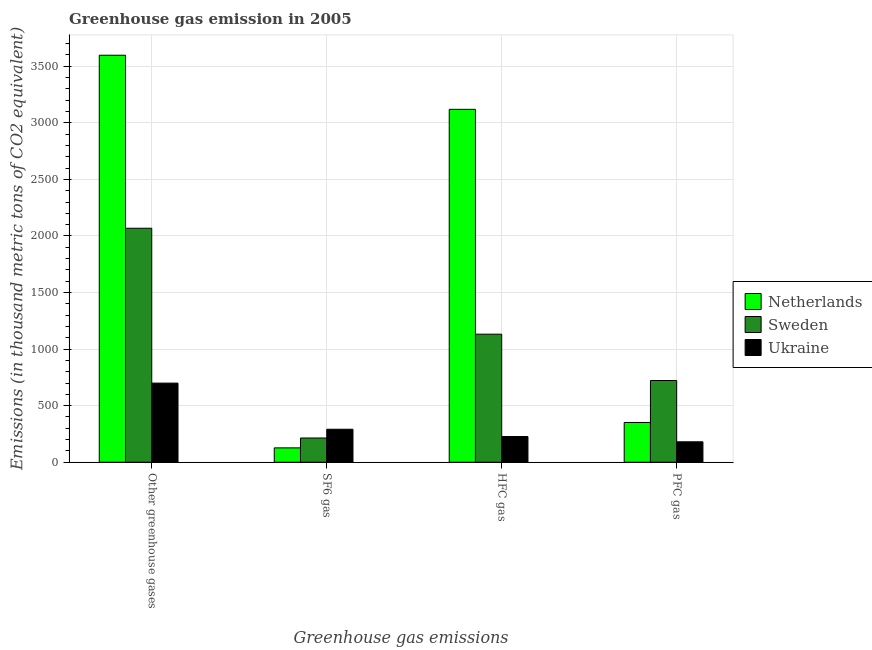How many groups of bars are there?
Your answer should be compact. 4. Are the number of bars per tick equal to the number of legend labels?
Keep it short and to the point. Yes. What is the label of the 2nd group of bars from the left?
Offer a terse response. SF6 gas. What is the emission of pfc gas in Sweden?
Offer a terse response. 722.3. Across all countries, what is the maximum emission of pfc gas?
Ensure brevity in your answer.  722.3. Across all countries, what is the minimum emission of hfc gas?
Make the answer very short. 227.2. In which country was the emission of pfc gas maximum?
Ensure brevity in your answer.  Sweden. What is the total emission of greenhouse gases in the graph?
Give a very brief answer. 6365.5. What is the difference between the emission of greenhouse gases in Netherlands and that in Ukraine?
Your answer should be very brief. 2898.5. What is the difference between the emission of pfc gas in Sweden and the emission of greenhouse gases in Netherlands?
Offer a terse response. -2875.5. What is the average emission of greenhouse gases per country?
Offer a terse response. 2121.83. What is the difference between the emission of hfc gas and emission of pfc gas in Sweden?
Make the answer very short. 409.6. What is the ratio of the emission of hfc gas in Sweden to that in Ukraine?
Make the answer very short. 4.98. What is the difference between the highest and the second highest emission of hfc gas?
Offer a very short reply. 1987.6. What is the difference between the highest and the lowest emission of greenhouse gases?
Give a very brief answer. 2898.5. What does the 3rd bar from the left in Other greenhouse gases represents?
Provide a succinct answer. Ukraine. What does the 1st bar from the right in SF6 gas represents?
Your response must be concise. Ukraine. How many bars are there?
Your answer should be very brief. 12. Are all the bars in the graph horizontal?
Your answer should be very brief. No. How many countries are there in the graph?
Keep it short and to the point. 3. Does the graph contain grids?
Provide a short and direct response. Yes. Where does the legend appear in the graph?
Your answer should be compact. Center right. How many legend labels are there?
Make the answer very short. 3. How are the legend labels stacked?
Give a very brief answer. Vertical. What is the title of the graph?
Offer a terse response. Greenhouse gas emission in 2005. Does "Zambia" appear as one of the legend labels in the graph?
Offer a terse response. No. What is the label or title of the X-axis?
Ensure brevity in your answer.  Greenhouse gas emissions. What is the label or title of the Y-axis?
Offer a terse response. Emissions (in thousand metric tons of CO2 equivalent). What is the Emissions (in thousand metric tons of CO2 equivalent) in Netherlands in Other greenhouse gases?
Your answer should be very brief. 3597.8. What is the Emissions (in thousand metric tons of CO2 equivalent) of Sweden in Other greenhouse gases?
Ensure brevity in your answer.  2068.4. What is the Emissions (in thousand metric tons of CO2 equivalent) of Ukraine in Other greenhouse gases?
Give a very brief answer. 699.3. What is the Emissions (in thousand metric tons of CO2 equivalent) of Netherlands in SF6 gas?
Provide a succinct answer. 126.9. What is the Emissions (in thousand metric tons of CO2 equivalent) in Sweden in SF6 gas?
Provide a succinct answer. 214.2. What is the Emissions (in thousand metric tons of CO2 equivalent) of Ukraine in SF6 gas?
Give a very brief answer. 291.6. What is the Emissions (in thousand metric tons of CO2 equivalent) in Netherlands in HFC gas?
Ensure brevity in your answer.  3119.5. What is the Emissions (in thousand metric tons of CO2 equivalent) in Sweden in HFC gas?
Provide a short and direct response. 1131.9. What is the Emissions (in thousand metric tons of CO2 equivalent) of Ukraine in HFC gas?
Your answer should be compact. 227.2. What is the Emissions (in thousand metric tons of CO2 equivalent) of Netherlands in PFC gas?
Keep it short and to the point. 351.4. What is the Emissions (in thousand metric tons of CO2 equivalent) of Sweden in PFC gas?
Make the answer very short. 722.3. What is the Emissions (in thousand metric tons of CO2 equivalent) in Ukraine in PFC gas?
Provide a succinct answer. 180.5. Across all Greenhouse gas emissions, what is the maximum Emissions (in thousand metric tons of CO2 equivalent) of Netherlands?
Offer a very short reply. 3597.8. Across all Greenhouse gas emissions, what is the maximum Emissions (in thousand metric tons of CO2 equivalent) of Sweden?
Offer a very short reply. 2068.4. Across all Greenhouse gas emissions, what is the maximum Emissions (in thousand metric tons of CO2 equivalent) of Ukraine?
Make the answer very short. 699.3. Across all Greenhouse gas emissions, what is the minimum Emissions (in thousand metric tons of CO2 equivalent) of Netherlands?
Provide a succinct answer. 126.9. Across all Greenhouse gas emissions, what is the minimum Emissions (in thousand metric tons of CO2 equivalent) of Sweden?
Your response must be concise. 214.2. Across all Greenhouse gas emissions, what is the minimum Emissions (in thousand metric tons of CO2 equivalent) of Ukraine?
Provide a succinct answer. 180.5. What is the total Emissions (in thousand metric tons of CO2 equivalent) in Netherlands in the graph?
Your answer should be very brief. 7195.6. What is the total Emissions (in thousand metric tons of CO2 equivalent) in Sweden in the graph?
Give a very brief answer. 4136.8. What is the total Emissions (in thousand metric tons of CO2 equivalent) in Ukraine in the graph?
Give a very brief answer. 1398.6. What is the difference between the Emissions (in thousand metric tons of CO2 equivalent) of Netherlands in Other greenhouse gases and that in SF6 gas?
Your response must be concise. 3470.9. What is the difference between the Emissions (in thousand metric tons of CO2 equivalent) of Sweden in Other greenhouse gases and that in SF6 gas?
Provide a short and direct response. 1854.2. What is the difference between the Emissions (in thousand metric tons of CO2 equivalent) of Ukraine in Other greenhouse gases and that in SF6 gas?
Ensure brevity in your answer.  407.7. What is the difference between the Emissions (in thousand metric tons of CO2 equivalent) of Netherlands in Other greenhouse gases and that in HFC gas?
Your answer should be compact. 478.3. What is the difference between the Emissions (in thousand metric tons of CO2 equivalent) of Sweden in Other greenhouse gases and that in HFC gas?
Offer a very short reply. 936.5. What is the difference between the Emissions (in thousand metric tons of CO2 equivalent) in Ukraine in Other greenhouse gases and that in HFC gas?
Your answer should be compact. 472.1. What is the difference between the Emissions (in thousand metric tons of CO2 equivalent) of Netherlands in Other greenhouse gases and that in PFC gas?
Your answer should be very brief. 3246.4. What is the difference between the Emissions (in thousand metric tons of CO2 equivalent) in Sweden in Other greenhouse gases and that in PFC gas?
Provide a succinct answer. 1346.1. What is the difference between the Emissions (in thousand metric tons of CO2 equivalent) of Ukraine in Other greenhouse gases and that in PFC gas?
Give a very brief answer. 518.8. What is the difference between the Emissions (in thousand metric tons of CO2 equivalent) of Netherlands in SF6 gas and that in HFC gas?
Make the answer very short. -2992.6. What is the difference between the Emissions (in thousand metric tons of CO2 equivalent) of Sweden in SF6 gas and that in HFC gas?
Keep it short and to the point. -917.7. What is the difference between the Emissions (in thousand metric tons of CO2 equivalent) of Ukraine in SF6 gas and that in HFC gas?
Your response must be concise. 64.4. What is the difference between the Emissions (in thousand metric tons of CO2 equivalent) of Netherlands in SF6 gas and that in PFC gas?
Offer a very short reply. -224.5. What is the difference between the Emissions (in thousand metric tons of CO2 equivalent) in Sweden in SF6 gas and that in PFC gas?
Your answer should be very brief. -508.1. What is the difference between the Emissions (in thousand metric tons of CO2 equivalent) of Ukraine in SF6 gas and that in PFC gas?
Offer a terse response. 111.1. What is the difference between the Emissions (in thousand metric tons of CO2 equivalent) in Netherlands in HFC gas and that in PFC gas?
Give a very brief answer. 2768.1. What is the difference between the Emissions (in thousand metric tons of CO2 equivalent) in Sweden in HFC gas and that in PFC gas?
Your answer should be compact. 409.6. What is the difference between the Emissions (in thousand metric tons of CO2 equivalent) in Ukraine in HFC gas and that in PFC gas?
Your response must be concise. 46.7. What is the difference between the Emissions (in thousand metric tons of CO2 equivalent) of Netherlands in Other greenhouse gases and the Emissions (in thousand metric tons of CO2 equivalent) of Sweden in SF6 gas?
Give a very brief answer. 3383.6. What is the difference between the Emissions (in thousand metric tons of CO2 equivalent) in Netherlands in Other greenhouse gases and the Emissions (in thousand metric tons of CO2 equivalent) in Ukraine in SF6 gas?
Your answer should be very brief. 3306.2. What is the difference between the Emissions (in thousand metric tons of CO2 equivalent) in Sweden in Other greenhouse gases and the Emissions (in thousand metric tons of CO2 equivalent) in Ukraine in SF6 gas?
Keep it short and to the point. 1776.8. What is the difference between the Emissions (in thousand metric tons of CO2 equivalent) in Netherlands in Other greenhouse gases and the Emissions (in thousand metric tons of CO2 equivalent) in Sweden in HFC gas?
Provide a short and direct response. 2465.9. What is the difference between the Emissions (in thousand metric tons of CO2 equivalent) in Netherlands in Other greenhouse gases and the Emissions (in thousand metric tons of CO2 equivalent) in Ukraine in HFC gas?
Keep it short and to the point. 3370.6. What is the difference between the Emissions (in thousand metric tons of CO2 equivalent) of Sweden in Other greenhouse gases and the Emissions (in thousand metric tons of CO2 equivalent) of Ukraine in HFC gas?
Give a very brief answer. 1841.2. What is the difference between the Emissions (in thousand metric tons of CO2 equivalent) of Netherlands in Other greenhouse gases and the Emissions (in thousand metric tons of CO2 equivalent) of Sweden in PFC gas?
Your answer should be compact. 2875.5. What is the difference between the Emissions (in thousand metric tons of CO2 equivalent) of Netherlands in Other greenhouse gases and the Emissions (in thousand metric tons of CO2 equivalent) of Ukraine in PFC gas?
Ensure brevity in your answer.  3417.3. What is the difference between the Emissions (in thousand metric tons of CO2 equivalent) of Sweden in Other greenhouse gases and the Emissions (in thousand metric tons of CO2 equivalent) of Ukraine in PFC gas?
Ensure brevity in your answer.  1887.9. What is the difference between the Emissions (in thousand metric tons of CO2 equivalent) of Netherlands in SF6 gas and the Emissions (in thousand metric tons of CO2 equivalent) of Sweden in HFC gas?
Your answer should be compact. -1005. What is the difference between the Emissions (in thousand metric tons of CO2 equivalent) in Netherlands in SF6 gas and the Emissions (in thousand metric tons of CO2 equivalent) in Ukraine in HFC gas?
Provide a short and direct response. -100.3. What is the difference between the Emissions (in thousand metric tons of CO2 equivalent) of Sweden in SF6 gas and the Emissions (in thousand metric tons of CO2 equivalent) of Ukraine in HFC gas?
Your answer should be compact. -13. What is the difference between the Emissions (in thousand metric tons of CO2 equivalent) of Netherlands in SF6 gas and the Emissions (in thousand metric tons of CO2 equivalent) of Sweden in PFC gas?
Keep it short and to the point. -595.4. What is the difference between the Emissions (in thousand metric tons of CO2 equivalent) in Netherlands in SF6 gas and the Emissions (in thousand metric tons of CO2 equivalent) in Ukraine in PFC gas?
Keep it short and to the point. -53.6. What is the difference between the Emissions (in thousand metric tons of CO2 equivalent) in Sweden in SF6 gas and the Emissions (in thousand metric tons of CO2 equivalent) in Ukraine in PFC gas?
Your answer should be very brief. 33.7. What is the difference between the Emissions (in thousand metric tons of CO2 equivalent) of Netherlands in HFC gas and the Emissions (in thousand metric tons of CO2 equivalent) of Sweden in PFC gas?
Your answer should be compact. 2397.2. What is the difference between the Emissions (in thousand metric tons of CO2 equivalent) in Netherlands in HFC gas and the Emissions (in thousand metric tons of CO2 equivalent) in Ukraine in PFC gas?
Provide a short and direct response. 2939. What is the difference between the Emissions (in thousand metric tons of CO2 equivalent) in Sweden in HFC gas and the Emissions (in thousand metric tons of CO2 equivalent) in Ukraine in PFC gas?
Your answer should be very brief. 951.4. What is the average Emissions (in thousand metric tons of CO2 equivalent) of Netherlands per Greenhouse gas emissions?
Offer a very short reply. 1798.9. What is the average Emissions (in thousand metric tons of CO2 equivalent) in Sweden per Greenhouse gas emissions?
Keep it short and to the point. 1034.2. What is the average Emissions (in thousand metric tons of CO2 equivalent) in Ukraine per Greenhouse gas emissions?
Offer a terse response. 349.65. What is the difference between the Emissions (in thousand metric tons of CO2 equivalent) in Netherlands and Emissions (in thousand metric tons of CO2 equivalent) in Sweden in Other greenhouse gases?
Keep it short and to the point. 1529.4. What is the difference between the Emissions (in thousand metric tons of CO2 equivalent) of Netherlands and Emissions (in thousand metric tons of CO2 equivalent) of Ukraine in Other greenhouse gases?
Your answer should be very brief. 2898.5. What is the difference between the Emissions (in thousand metric tons of CO2 equivalent) in Sweden and Emissions (in thousand metric tons of CO2 equivalent) in Ukraine in Other greenhouse gases?
Your response must be concise. 1369.1. What is the difference between the Emissions (in thousand metric tons of CO2 equivalent) in Netherlands and Emissions (in thousand metric tons of CO2 equivalent) in Sweden in SF6 gas?
Your answer should be compact. -87.3. What is the difference between the Emissions (in thousand metric tons of CO2 equivalent) of Netherlands and Emissions (in thousand metric tons of CO2 equivalent) of Ukraine in SF6 gas?
Provide a succinct answer. -164.7. What is the difference between the Emissions (in thousand metric tons of CO2 equivalent) of Sweden and Emissions (in thousand metric tons of CO2 equivalent) of Ukraine in SF6 gas?
Your answer should be compact. -77.4. What is the difference between the Emissions (in thousand metric tons of CO2 equivalent) in Netherlands and Emissions (in thousand metric tons of CO2 equivalent) in Sweden in HFC gas?
Offer a very short reply. 1987.6. What is the difference between the Emissions (in thousand metric tons of CO2 equivalent) of Netherlands and Emissions (in thousand metric tons of CO2 equivalent) of Ukraine in HFC gas?
Provide a succinct answer. 2892.3. What is the difference between the Emissions (in thousand metric tons of CO2 equivalent) in Sweden and Emissions (in thousand metric tons of CO2 equivalent) in Ukraine in HFC gas?
Provide a succinct answer. 904.7. What is the difference between the Emissions (in thousand metric tons of CO2 equivalent) in Netherlands and Emissions (in thousand metric tons of CO2 equivalent) in Sweden in PFC gas?
Give a very brief answer. -370.9. What is the difference between the Emissions (in thousand metric tons of CO2 equivalent) in Netherlands and Emissions (in thousand metric tons of CO2 equivalent) in Ukraine in PFC gas?
Provide a short and direct response. 170.9. What is the difference between the Emissions (in thousand metric tons of CO2 equivalent) of Sweden and Emissions (in thousand metric tons of CO2 equivalent) of Ukraine in PFC gas?
Provide a succinct answer. 541.8. What is the ratio of the Emissions (in thousand metric tons of CO2 equivalent) of Netherlands in Other greenhouse gases to that in SF6 gas?
Give a very brief answer. 28.35. What is the ratio of the Emissions (in thousand metric tons of CO2 equivalent) of Sweden in Other greenhouse gases to that in SF6 gas?
Offer a terse response. 9.66. What is the ratio of the Emissions (in thousand metric tons of CO2 equivalent) of Ukraine in Other greenhouse gases to that in SF6 gas?
Make the answer very short. 2.4. What is the ratio of the Emissions (in thousand metric tons of CO2 equivalent) in Netherlands in Other greenhouse gases to that in HFC gas?
Make the answer very short. 1.15. What is the ratio of the Emissions (in thousand metric tons of CO2 equivalent) of Sweden in Other greenhouse gases to that in HFC gas?
Keep it short and to the point. 1.83. What is the ratio of the Emissions (in thousand metric tons of CO2 equivalent) of Ukraine in Other greenhouse gases to that in HFC gas?
Provide a succinct answer. 3.08. What is the ratio of the Emissions (in thousand metric tons of CO2 equivalent) of Netherlands in Other greenhouse gases to that in PFC gas?
Keep it short and to the point. 10.24. What is the ratio of the Emissions (in thousand metric tons of CO2 equivalent) of Sweden in Other greenhouse gases to that in PFC gas?
Provide a succinct answer. 2.86. What is the ratio of the Emissions (in thousand metric tons of CO2 equivalent) of Ukraine in Other greenhouse gases to that in PFC gas?
Ensure brevity in your answer.  3.87. What is the ratio of the Emissions (in thousand metric tons of CO2 equivalent) in Netherlands in SF6 gas to that in HFC gas?
Offer a very short reply. 0.04. What is the ratio of the Emissions (in thousand metric tons of CO2 equivalent) in Sweden in SF6 gas to that in HFC gas?
Give a very brief answer. 0.19. What is the ratio of the Emissions (in thousand metric tons of CO2 equivalent) of Ukraine in SF6 gas to that in HFC gas?
Offer a very short reply. 1.28. What is the ratio of the Emissions (in thousand metric tons of CO2 equivalent) in Netherlands in SF6 gas to that in PFC gas?
Ensure brevity in your answer.  0.36. What is the ratio of the Emissions (in thousand metric tons of CO2 equivalent) of Sweden in SF6 gas to that in PFC gas?
Keep it short and to the point. 0.3. What is the ratio of the Emissions (in thousand metric tons of CO2 equivalent) in Ukraine in SF6 gas to that in PFC gas?
Provide a short and direct response. 1.62. What is the ratio of the Emissions (in thousand metric tons of CO2 equivalent) of Netherlands in HFC gas to that in PFC gas?
Your answer should be very brief. 8.88. What is the ratio of the Emissions (in thousand metric tons of CO2 equivalent) of Sweden in HFC gas to that in PFC gas?
Give a very brief answer. 1.57. What is the ratio of the Emissions (in thousand metric tons of CO2 equivalent) in Ukraine in HFC gas to that in PFC gas?
Make the answer very short. 1.26. What is the difference between the highest and the second highest Emissions (in thousand metric tons of CO2 equivalent) in Netherlands?
Offer a very short reply. 478.3. What is the difference between the highest and the second highest Emissions (in thousand metric tons of CO2 equivalent) in Sweden?
Provide a short and direct response. 936.5. What is the difference between the highest and the second highest Emissions (in thousand metric tons of CO2 equivalent) in Ukraine?
Your answer should be very brief. 407.7. What is the difference between the highest and the lowest Emissions (in thousand metric tons of CO2 equivalent) in Netherlands?
Provide a succinct answer. 3470.9. What is the difference between the highest and the lowest Emissions (in thousand metric tons of CO2 equivalent) in Sweden?
Keep it short and to the point. 1854.2. What is the difference between the highest and the lowest Emissions (in thousand metric tons of CO2 equivalent) of Ukraine?
Your answer should be very brief. 518.8. 